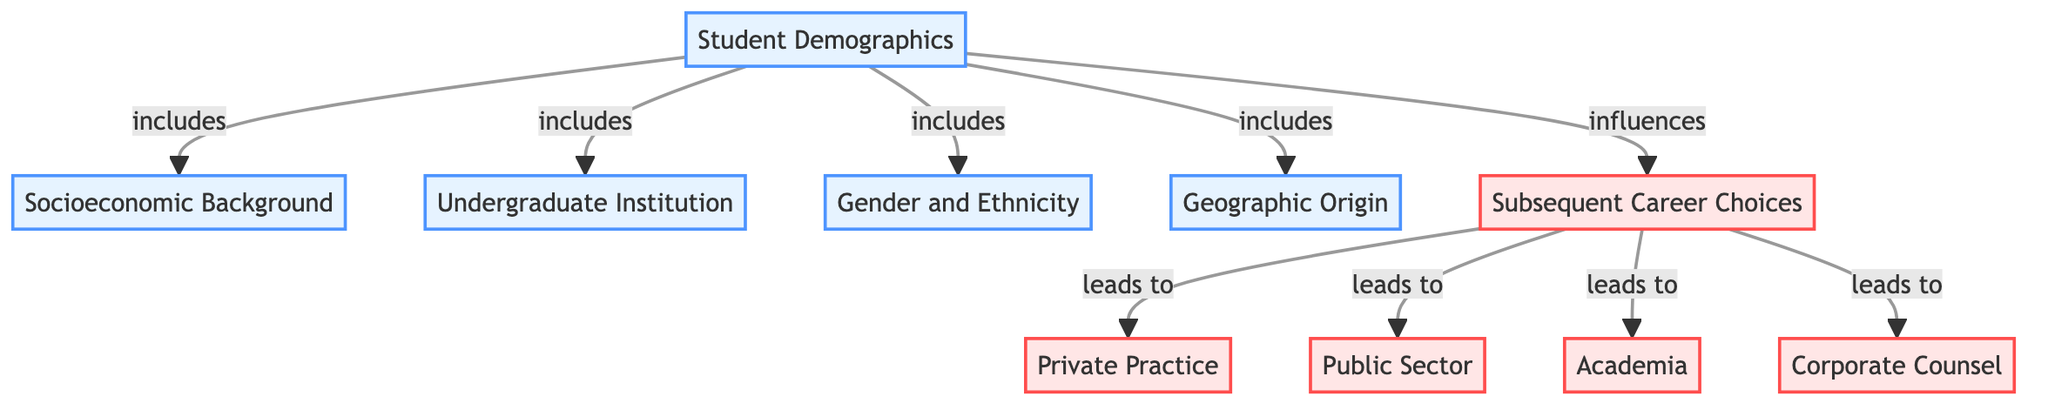What are the components of student demographics? The diagram indicates four components under the "Student Demographics" node: Socioeconomic Background, Undergraduate Institution, Gender and Ethnicity, and Geographic Origin.
Answer: Socioeconomic Background, Undergraduate Institution, Gender and Ethnicity, Geographic Origin How many subsequent career choices are indicated in the diagram? There are four career choices listed under the "Subsequent Career Choices" node: Private Practice, Public Sector, Academia, and Corporate Counsel.
Answer: Four Which demographic factor directly influences career choices? The diagram indicates that "Student Demographics" influences "Subsequent Career Choices." The line connecting these two nodes shows this direction.
Answer: Student Demographics What leads to Private Practice? "Subsequent Career Choices" node indicates that it leads to Private Practice, as shown by the arrow connecting them.
Answer: Subsequent Career Choices What is the relationship between Gender and Ethnicity and Subsequent Career Choices? The diagram shows that Gender and Ethnicity are part of the "Student Demographics" which influence the "Subsequent Career Choices." This indicates a directional influence.
Answer: Influences How many different demographic categories are represented? The diagram has a total of four distinct demographic categories represented as nodes under "Student Demographics."
Answer: Four Is Corporate Counsel influenced by Student Demographics? Yes, the diagram shows that "Subsequent Career Choices," which Corporate Counsel is part of, is influenced by "Student Demographics." This implies a connection.
Answer: Yes What are the subsequent career choices after legal education? The subsequent career choices after legal education indicated in the diagram are Private Practice, Public Sector, Academia, and Corporate Counsel.
Answer: Private Practice, Public Sector, Academia, Corporate Counsel Does Geographic Origin have an influence on career choices? Yes, Geographic Origin is listed among the components of Student Demographics, which influences Subsequent Career Choices, making the relationship evident.
Answer: Yes 